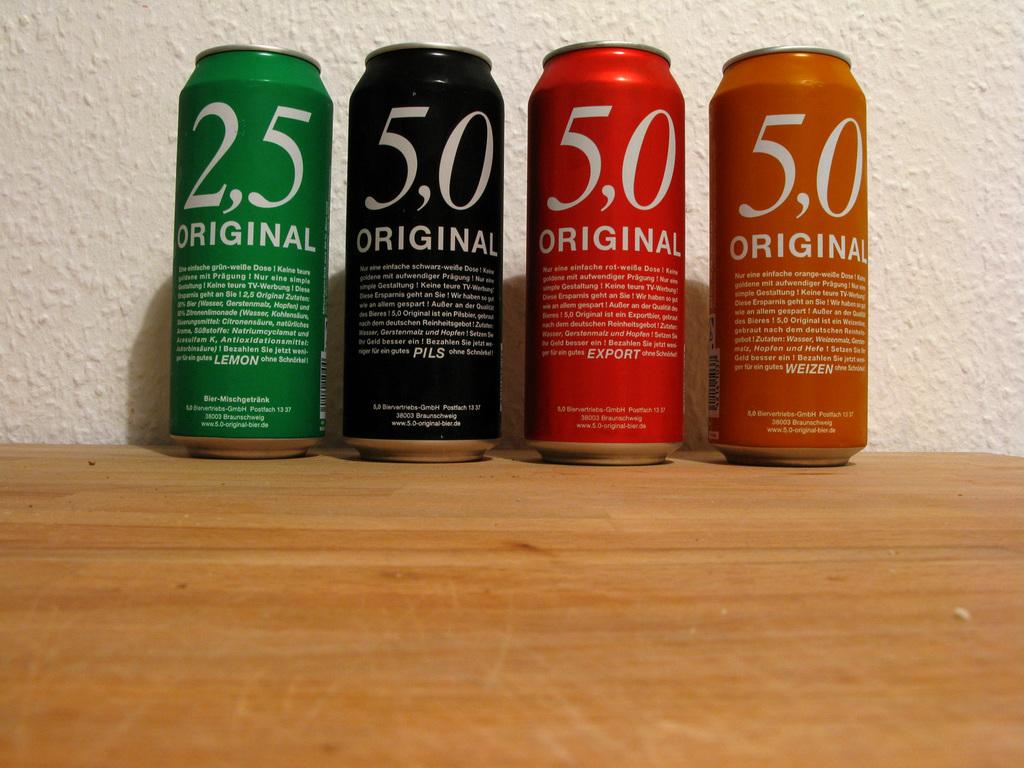What number is on the green can?
Your response must be concise. 2,5. 